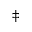Convert formula to latex. <formula><loc_0><loc_0><loc_500><loc_500>^ { \ddagger }</formula> 